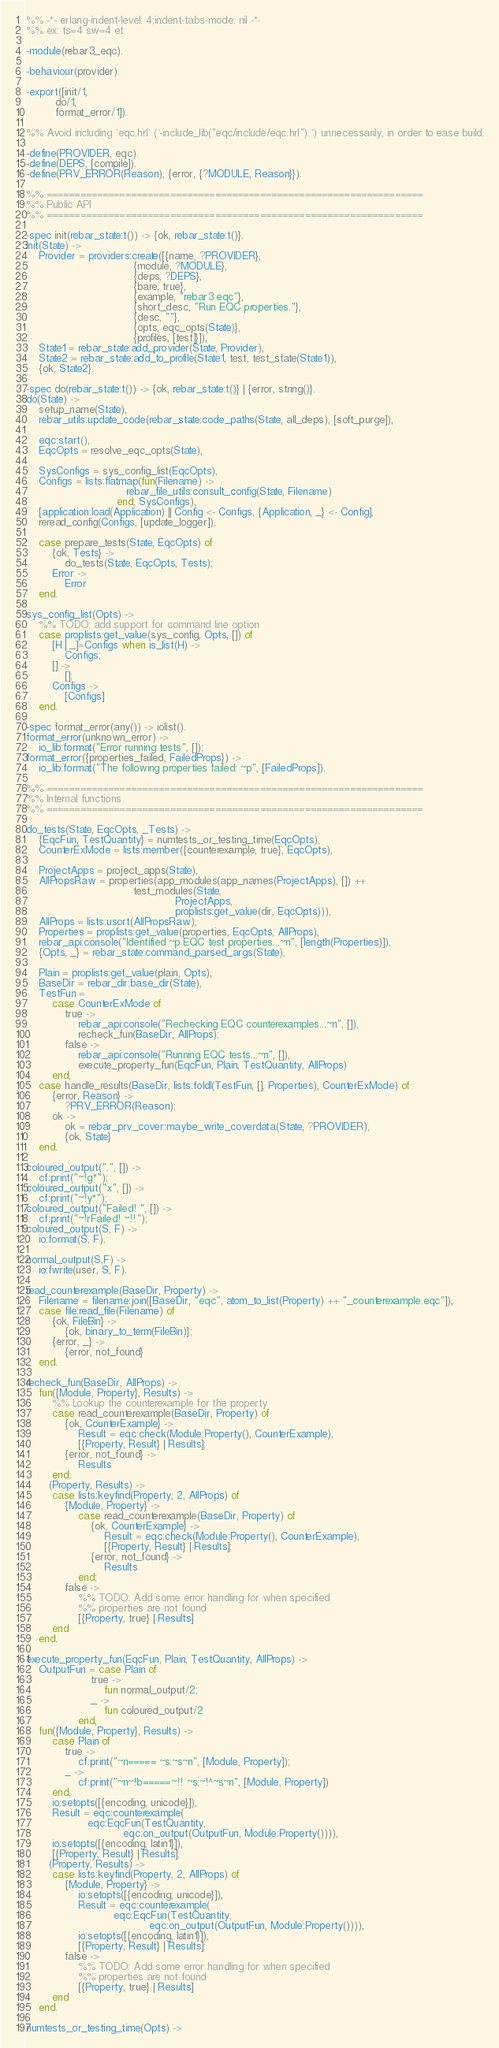Convert code to text. <code><loc_0><loc_0><loc_500><loc_500><_Erlang_>%% -*- erlang-indent-level: 4;indent-tabs-mode: nil -*-
%% ex: ts=4 sw=4 et

-module(rebar3_eqc).

-behaviour(provider).

-export([init/1,
         do/1,
         format_error/1]).

%% Avoid including `eqc.hrl` (`-include_lib("eqc/include/eqc.hrl").`) unnecessarily, in order to ease build.

-define(PROVIDER, eqc).
-define(DEPS, [compile]).
-define(PRV_ERROR(Reason), {error, {?MODULE, Reason}}).

%% ===================================================================
%% Public API
%% ===================================================================

-spec init(rebar_state:t()) -> {ok, rebar_state:t()}.
init(State) ->
    Provider = providers:create([{name, ?PROVIDER},
                                 {module, ?MODULE},
                                 {deps, ?DEPS},
                                 {bare, true},
                                 {example, "rebar3 eqc"},
                                 {short_desc, "Run EQC properties."},
                                 {desc, ""},
                                 {opts, eqc_opts(State)},
                                 {profiles, [test]}]),
    State1 = rebar_state:add_provider(State, Provider),
    State2 = rebar_state:add_to_profile(State1, test, test_state(State1)),
    {ok, State2}.

-spec do(rebar_state:t()) -> {ok, rebar_state:t()} | {error, string()}.
do(State) ->
    setup_name(State),
    rebar_utils:update_code(rebar_state:code_paths(State, all_deps), [soft_purge]),

    eqc:start(),
    EqcOpts = resolve_eqc_opts(State),

    SysConfigs = sys_config_list(EqcOpts),
    Configs = lists:flatmap(fun(Filename) ->
                               rebar_file_utils:consult_config(State, Filename)
                            end, SysConfigs),
    [application:load(Application) || Config <- Configs, {Application, _} <- Config],
    reread_config(Configs, [update_logger]),

    case prepare_tests(State, EqcOpts) of
        {ok, Tests} ->
            do_tests(State, EqcOpts, Tests);
        Error ->
            Error
    end.

sys_config_list(Opts) ->
    %% TODO: add support for command line option
    case proplists:get_value(sys_config, Opts, []) of
        [H | _]=Configs when is_list(H) ->
            Configs;
        [] ->
            [];
        Configs ->
            [Configs]
    end.

-spec format_error(any()) -> iolist().
format_error(unknown_error) ->
    io_lib:format("Error running tests", []);
format_error({properties_failed, FailedProps}) ->
    io_lib:format("The following properties failed: ~p", [FailedProps]).

%% ===================================================================
%% Internal functions
%% ===================================================================

do_tests(State, EqcOpts, _Tests) ->
    {EqcFun, TestQuantity} = numtests_or_testing_time(EqcOpts),
    CounterExMode = lists:member({counterexample, true}, EqcOpts),

    ProjectApps = project_apps(State),
    AllPropsRaw = properties(app_modules(app_names(ProjectApps), []) ++
                                 test_modules(State,
                                              ProjectApps,
                                              proplists:get_value(dir, EqcOpts))),
    AllProps = lists:usort(AllPropsRaw),
    Properties = proplists:get_value(properties, EqcOpts, AllProps),
    rebar_api:console("Identified ~p EQC test properties...~n", [length(Properties)]),
    {Opts, _} = rebar_state:command_parsed_args(State),

    Plain = proplists:get_value(plain, Opts),
    BaseDir = rebar_dir:base_dir(State),
    TestFun =
        case CounterExMode of
            true ->
                rebar_api:console("Rechecking EQC counterexamples...~n", []),
                recheck_fun(BaseDir, AllProps);
            false ->
                rebar_api:console("Running EQC tests...~n", []),
                execute_property_fun(EqcFun, Plain, TestQuantity, AllProps)
        end,
    case handle_results(BaseDir, lists:foldl(TestFun, [], Properties), CounterExMode) of
        {error, Reason} ->
            ?PRV_ERROR(Reason);
        ok ->
            ok = rebar_prv_cover:maybe_write_coverdata(State, ?PROVIDER),
            {ok, State}
    end.

coloured_output(".", []) ->
    cf:print("~!g*");
coloured_output("x", []) ->
    cf:print("~!y*");
coloured_output("Failed! ", []) ->
    cf:print("~!rFailed! ~!!");
coloured_output(S, F) ->
    io:format(S, F).

normal_output(S,F) ->
    io:fwrite(user, S, F).

read_counterexample(BaseDir, Property) ->
    Filename = filename:join([BaseDir, "eqc", atom_to_list(Property) ++ "_counterexample.eqc"]),
    case file:read_file(Filename) of
        {ok, FileBin} ->
            {ok, binary_to_term(FileBin)};
        {error, _} ->
            {error, not_found}
    end.

recheck_fun(BaseDir, AllProps) ->
    fun({Module, Property}, Results) ->
        %% Lookup the counterexample for the property
        case read_counterexample(BaseDir, Property) of
            {ok, CounterExample} ->
                Result = eqc:check(Module:Property(), CounterExample),
                [{Property, Result} | Results];
            {error, not_found} ->
                Results
        end;
       (Property, Results) ->
        case lists:keyfind(Property, 2, AllProps) of
            {Module, Property} ->
                case read_counterexample(BaseDir, Property) of
                    {ok, CounterExample} ->
                        Result = eqc:check(Module:Property(), CounterExample),
                        [{Property, Result} | Results];
                    {error, not_found} ->
                        Results
                end;
            false ->
                %% TODO: Add some error handling for when specified
                %% properties are not found
                [{Property, true} | Results]
        end
    end.

execute_property_fun(EqcFun, Plain, TestQuantity, AllProps) ->
    OutputFun = case Plain of
                    true ->
                        fun normal_output/2;
                    _ ->
                        fun coloured_output/2
                end,
    fun({Module, Property}, Results) ->
        case Plain of
            true ->
                cf:print("~n===== ~s:~s~n", [Module, Property]);
            _ ->
                cf:print("~n~!b=====~!! ~s:~!^~s~n", [Module, Property])
        end,
        io:setopts([{encoding, unicode}]),
        Result = eqc:counterexample(
                   eqc:EqcFun(TestQuantity,
                              eqc:on_output(OutputFun, Module:Property()))),
        io:setopts([{encoding, latin1}]),
        [{Property, Result} | Results];
       (Property, Results) ->
        case lists:keyfind(Property, 2, AllProps) of
            {Module, Property} ->
                io:setopts([{encoding, unicode}]),
                Result = eqc:counterexample(
                           eqc:EqcFun(TestQuantity,
                                      eqc:on_output(OutputFun, Module:Property()))),
                io:setopts([{encoding, latin1}]),
                [{Property, Result} | Results];
            false ->
                %% TODO: Add some error handling for when specified
                %% properties are not found
                [{Property, true} | Results]
        end
    end.

numtests_or_testing_time(Opts) -></code> 